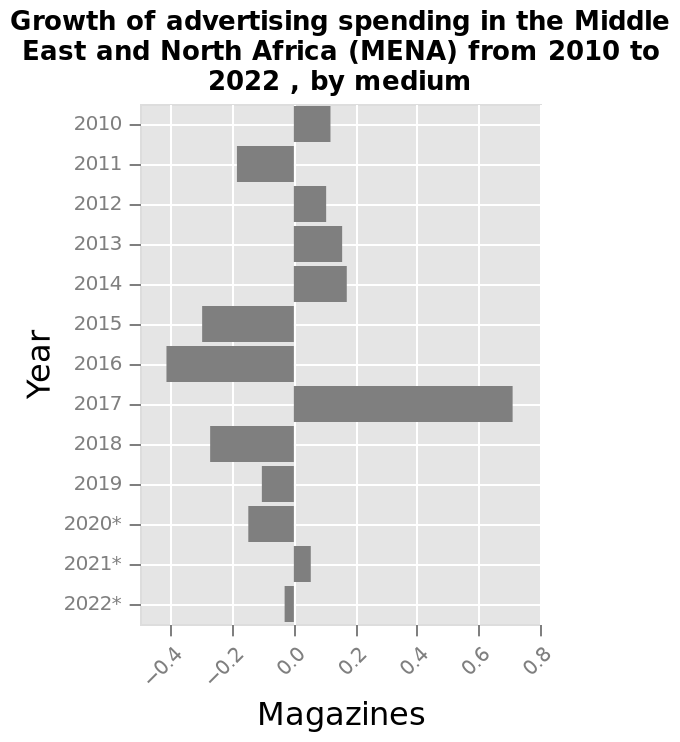<image>
What is the value on the x-axis corresponding to the end of the scale? The value on the x-axis corresponding to the end of the scale is 0.8. How many years out of the 13 years have shown growth in sales?  Seven years out of the 13 years have shown growth in sales. Did the spend consistently grow or shrink in the observed years? No, there is no consistent pattern as the spend grows and shrinks in different years. 